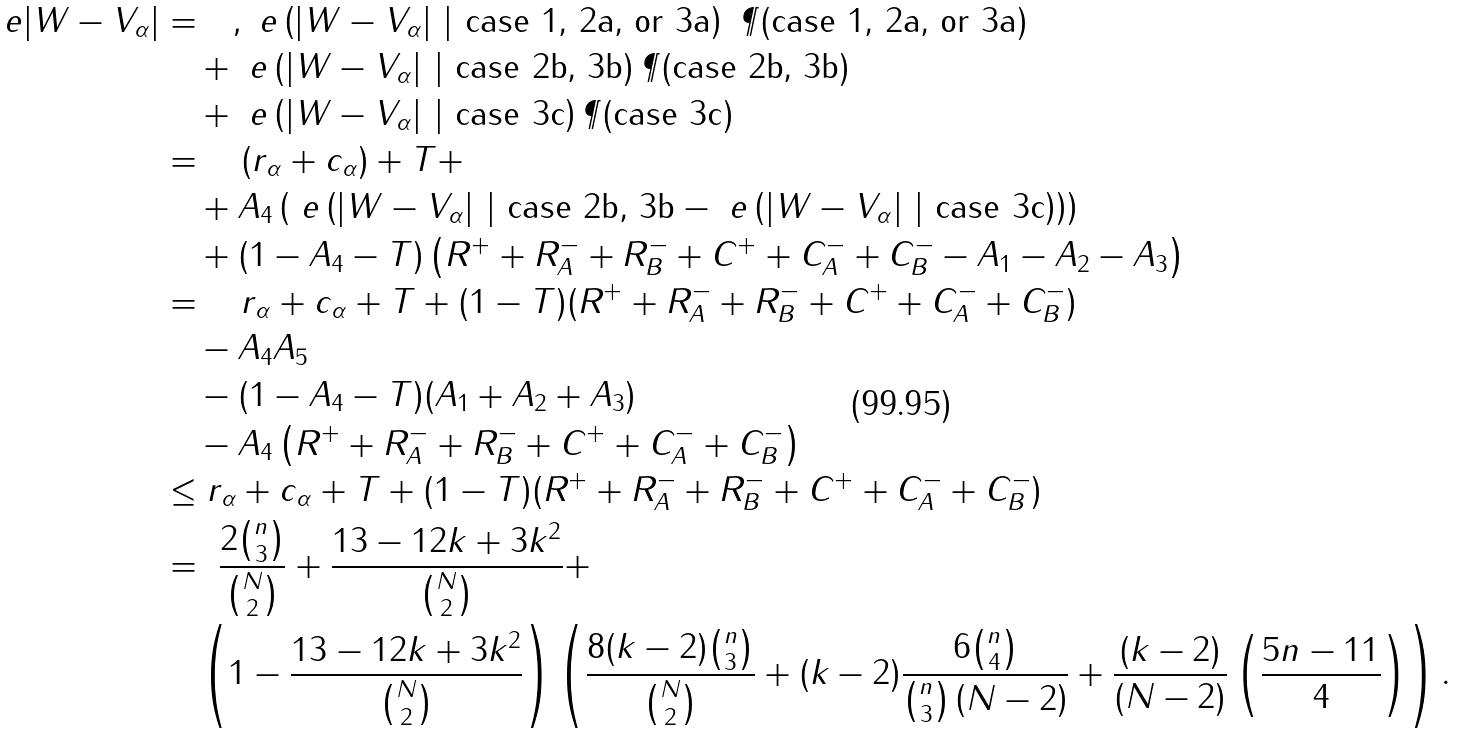<formula> <loc_0><loc_0><loc_500><loc_500>\ e | W - V _ { \alpha } | & = \quad , \ e \left ( | W - V _ { \alpha } | \ | \text { case 1, 2a, or 3a} \right ) \ \P ( \text {case 1, 2a, or 3a} ) \\ & \quad + \ e \left ( | W - V _ { \alpha } | \ | \text { case 2b, 3b} \right ) \P ( \text {case 2b, 3b} ) \\ & \quad + \ e \left ( | W - V _ { \alpha } | \ | \text { case 3c} \right ) \P ( \text {case 3c} ) \\ & = \quad ( r _ { \alpha } + c _ { \alpha } ) + T + \\ & \quad + A _ { 4 } \left ( \ e \left ( | W - V _ { \alpha } | \ | \text { case 2b, 3b} - \ e \left ( | W - V _ { \alpha } | \ | \text { case 3c} \right ) \right ) \right ) \\ & \quad + ( 1 - A _ { 4 } - T ) \left ( R ^ { + } + R _ { A } ^ { - } + R _ { B } ^ { - } + C ^ { + } + C _ { A } ^ { - } + C _ { B } ^ { - } - A _ { 1 } - A _ { 2 } - A _ { 3 } \right ) \\ & = \quad r _ { \alpha } + c _ { \alpha } + T + ( 1 - T ) ( R ^ { + } + R _ { A } ^ { - } + R _ { B } ^ { - } + C ^ { + } + C _ { A } ^ { - } + C _ { B } ^ { - } ) \\ & \quad - A _ { 4 } A _ { 5 } \\ & \quad - ( 1 - A _ { 4 } - T ) ( A _ { 1 } + A _ { 2 } + A _ { 3 } ) \\ & \quad - A _ { 4 } \left ( R ^ { + } + R _ { A } ^ { - } + R _ { B } ^ { - } + C ^ { + } + C _ { A } ^ { - } + C _ { B } ^ { - } \right ) \\ & \leq r _ { \alpha } + c _ { \alpha } + T + ( 1 - T ) ( R ^ { + } + R _ { A } ^ { - } + R _ { B } ^ { - } + C ^ { + } + C _ { A } ^ { - } + C _ { B } ^ { - } ) \\ & = \ \frac { 2 \binom { n } { 3 } } { \binom { N } { 2 } } + \frac { 1 3 - 1 2 k + 3 k ^ { 2 } } { \binom { N } { 2 } } + \\ & \quad \left ( 1 - \frac { 1 3 - 1 2 k + 3 k ^ { 2 } } { \binom { N } { 2 } } \right ) \left ( \frac { 8 ( k - 2 ) \binom { n } { 3 } } { \binom { N } { 2 } } + ( k - 2 ) \frac { 6 \binom { n } { 4 } } { \binom { n } { 3 } \left ( N - 2 \right ) } + \frac { ( k - 2 ) } { \left ( N - 2 \right ) } \left ( \frac { 5 n - 1 1 } { 4 } \right ) \right ) . \\</formula> 